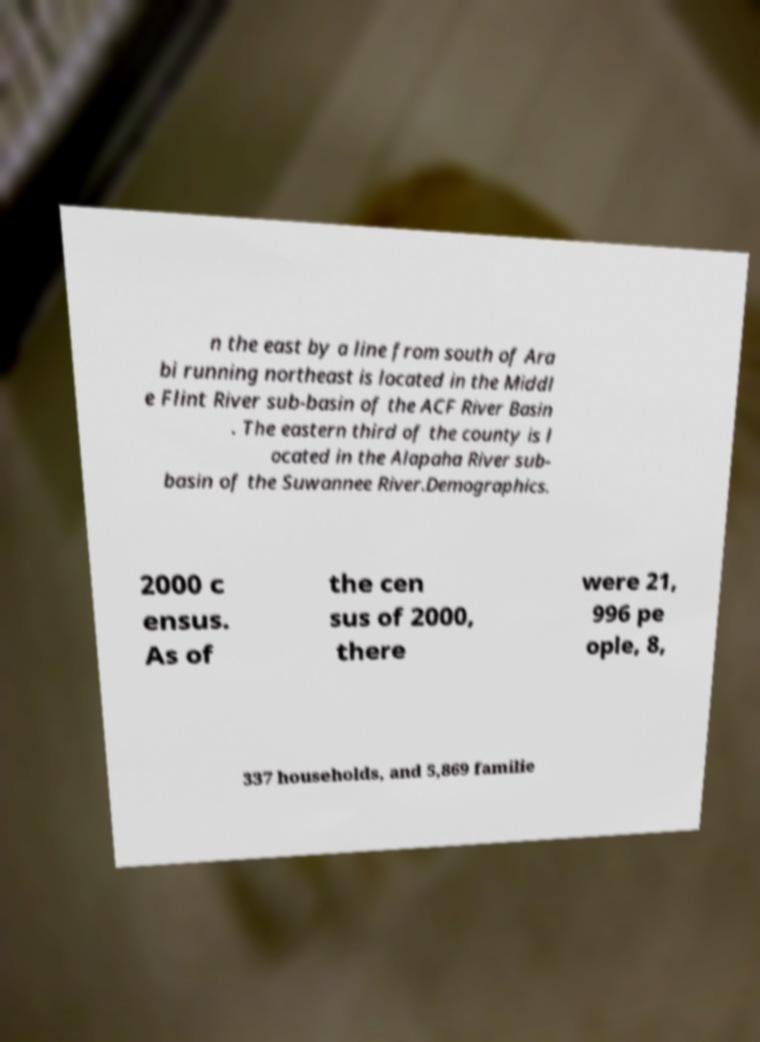I need the written content from this picture converted into text. Can you do that? n the east by a line from south of Ara bi running northeast is located in the Middl e Flint River sub-basin of the ACF River Basin . The eastern third of the county is l ocated in the Alapaha River sub- basin of the Suwannee River.Demographics. 2000 c ensus. As of the cen sus of 2000, there were 21, 996 pe ople, 8, 337 households, and 5,869 familie 